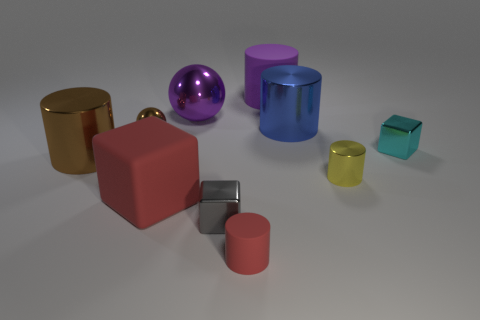Subtract all large cylinders. How many cylinders are left? 2 Subtract all blue cylinders. How many cylinders are left? 4 Subtract all blue cubes. Subtract all yellow cylinders. How many cubes are left? 3 Subtract all spheres. How many objects are left? 8 Subtract 0 yellow cubes. How many objects are left? 10 Subtract all tiny yellow matte cylinders. Subtract all big purple cylinders. How many objects are left? 9 Add 4 tiny cyan objects. How many tiny cyan objects are left? 5 Add 8 big yellow objects. How many big yellow objects exist? 8 